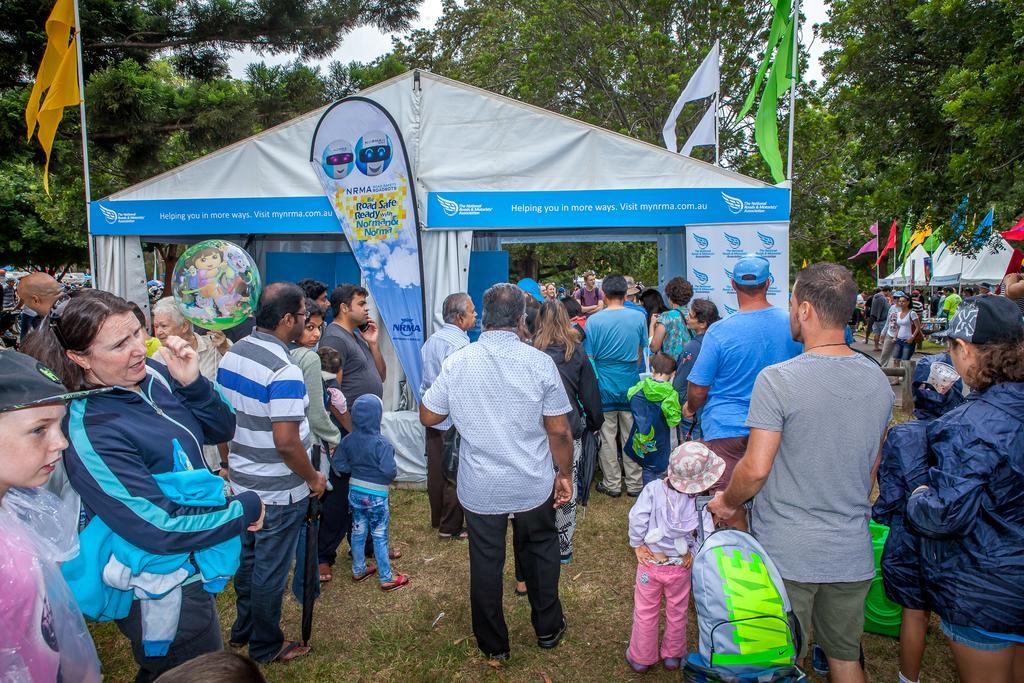Could you give a brief overview of what you see in this image? In this image I can see the group of people standing in-front of the tent. These people are wearing the different color dresses and I can see few people with the hats and caps. The tent is in blue and ash color and there are flags to the side of the tent. The flags are in different color. In the back there are many trees and the white sky. I can also see some bags holding the people. 